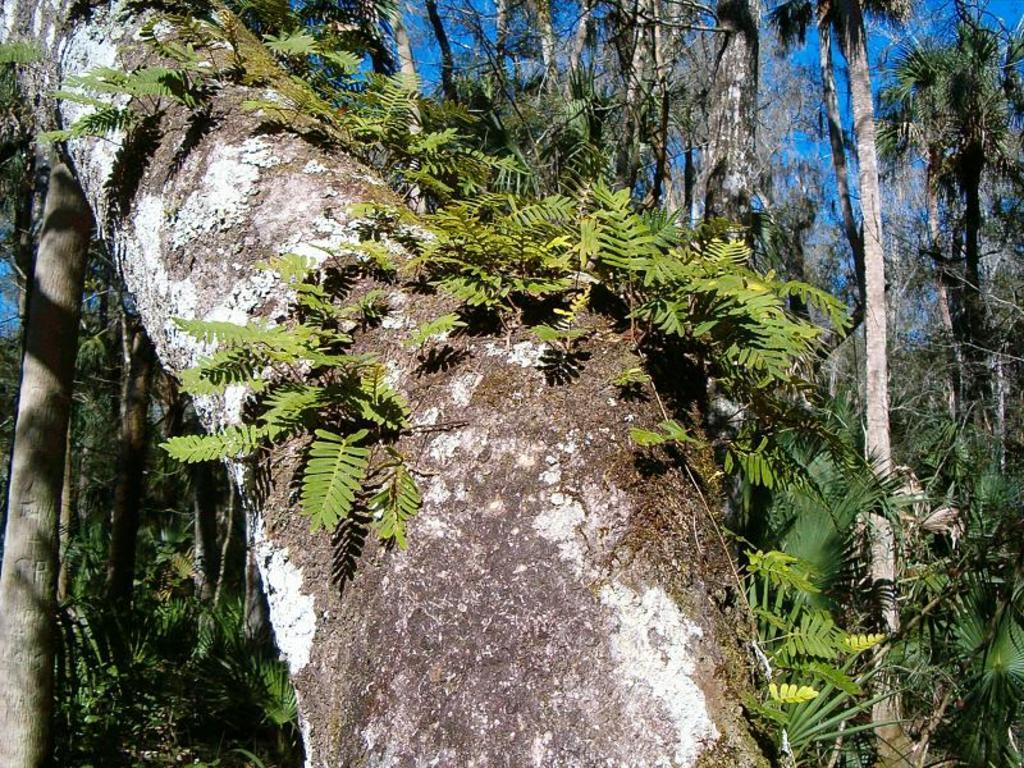What is present on the tree branch in the image? There are plants on the tree branch in the image. What else can be seen in the image besides the tree branch? Plants, trees, and the sky are visible in the background of the image. Can you describe the plants and trees in the background? Plants and trees are visible in the background of the image. What part of the natural environment is visible in the image? The sky is partially visible in the background of the image. What type of dirt can be seen on the church in the image? There is no church present in the image, so it is not possible to determine what type of dirt might be on it. 